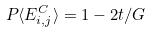<formula> <loc_0><loc_0><loc_500><loc_500>P \langle E _ { i , j } ^ { C } \rangle = 1 - 2 t / G</formula> 